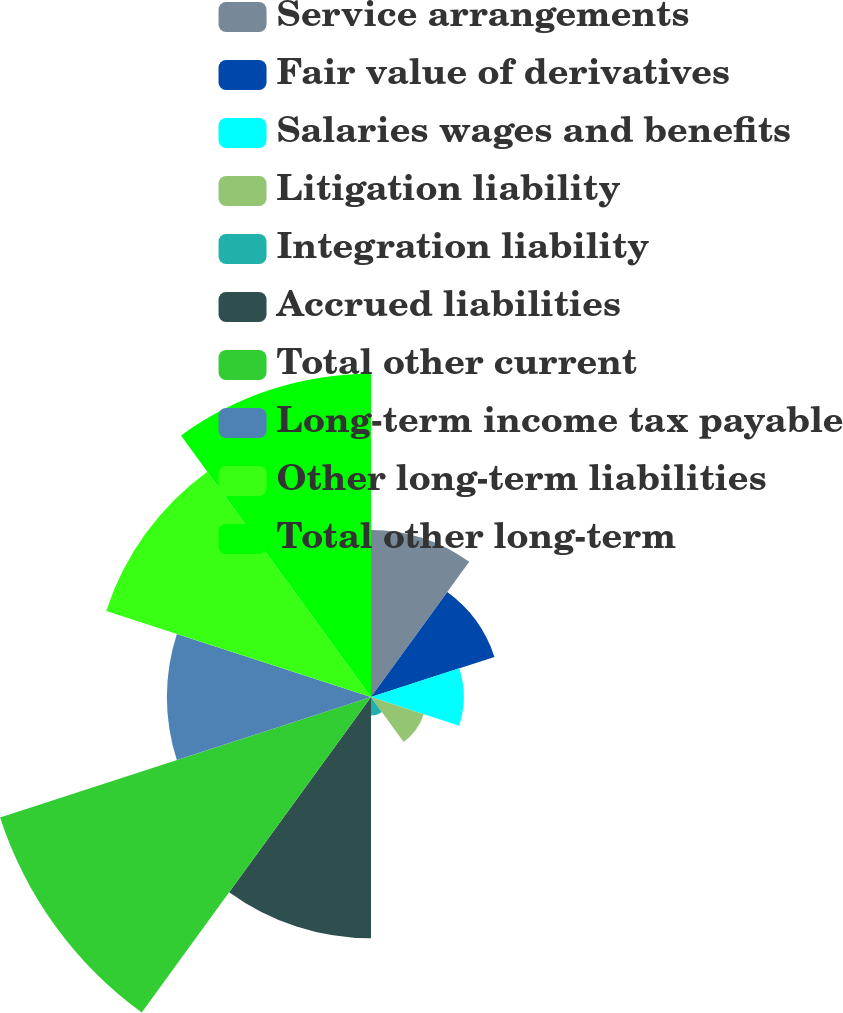Convert chart. <chart><loc_0><loc_0><loc_500><loc_500><pie_chart><fcel>Service arrangements<fcel>Fair value of derivatives<fcel>Salaries wages and benefits<fcel>Litigation liability<fcel>Integration liability<fcel>Accrued liabilities<fcel>Total other current<fcel>Long-term income tax payable<fcel>Other long-term liabilities<fcel>Total other long-term<nl><fcel>8.79%<fcel>6.83%<fcel>4.88%<fcel>2.92%<fcel>0.97%<fcel>12.7%<fcel>20.52%<fcel>10.74%<fcel>14.65%<fcel>17.01%<nl></chart> 